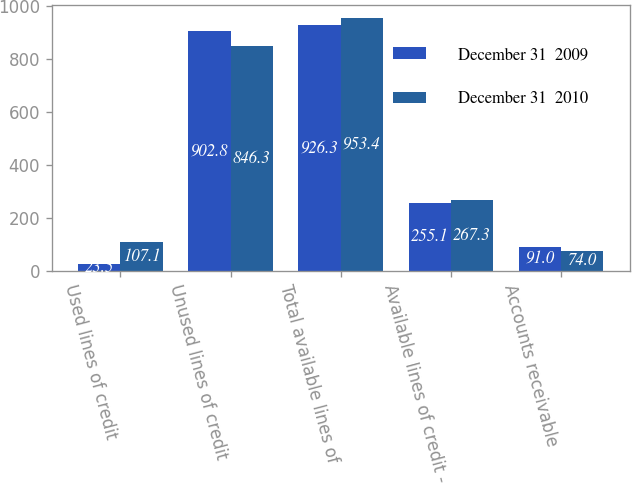Convert chart. <chart><loc_0><loc_0><loc_500><loc_500><stacked_bar_chart><ecel><fcel>Used lines of credit<fcel>Unused lines of credit<fcel>Total available lines of<fcel>Available lines of credit -<fcel>Accounts receivable<nl><fcel>December 31  2009<fcel>23.5<fcel>902.8<fcel>926.3<fcel>255.1<fcel>91<nl><fcel>December 31  2010<fcel>107.1<fcel>846.3<fcel>953.4<fcel>267.3<fcel>74<nl></chart> 